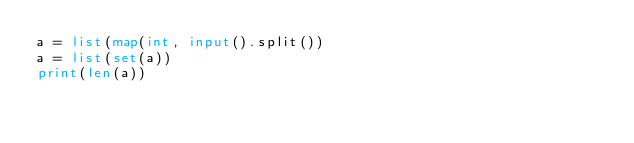<code> <loc_0><loc_0><loc_500><loc_500><_Python_>a = list(map(int, input().split())
a = list(set(a))
print(len(a))</code> 